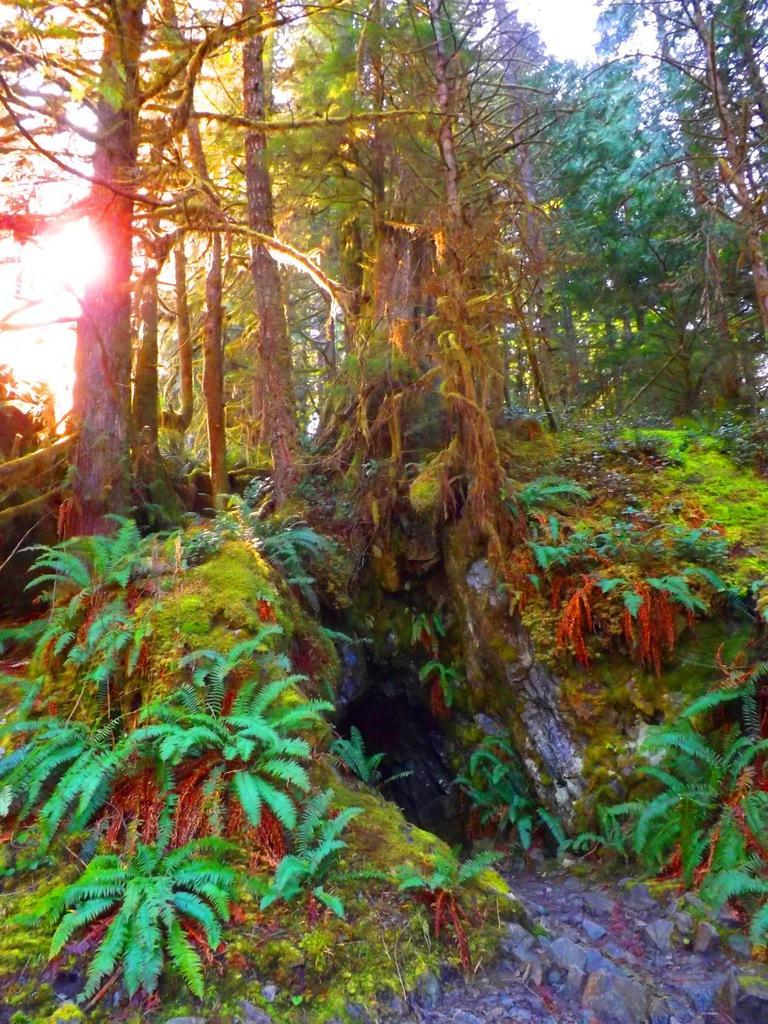Could you give a brief overview of what you see in this image? In this image I can see colorful design trees and I can see a sun light on the left side , at the top I can see the sky 